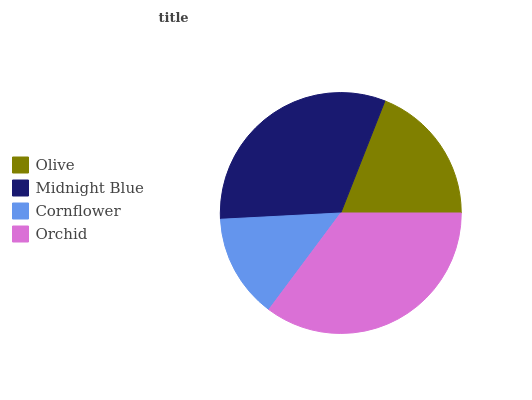Is Cornflower the minimum?
Answer yes or no. Yes. Is Orchid the maximum?
Answer yes or no. Yes. Is Midnight Blue the minimum?
Answer yes or no. No. Is Midnight Blue the maximum?
Answer yes or no. No. Is Midnight Blue greater than Olive?
Answer yes or no. Yes. Is Olive less than Midnight Blue?
Answer yes or no. Yes. Is Olive greater than Midnight Blue?
Answer yes or no. No. Is Midnight Blue less than Olive?
Answer yes or no. No. Is Midnight Blue the high median?
Answer yes or no. Yes. Is Olive the low median?
Answer yes or no. Yes. Is Cornflower the high median?
Answer yes or no. No. Is Midnight Blue the low median?
Answer yes or no. No. 